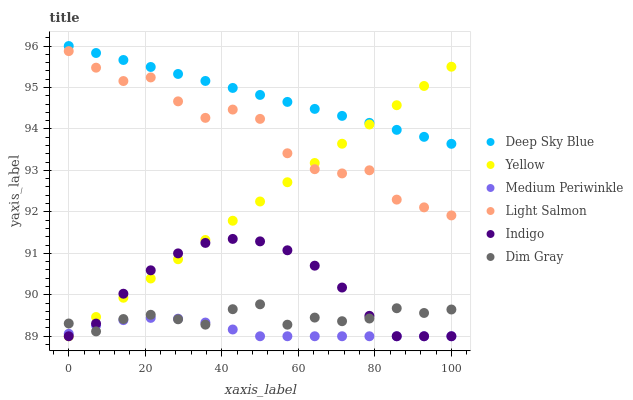Does Medium Periwinkle have the minimum area under the curve?
Answer yes or no. Yes. Does Deep Sky Blue have the maximum area under the curve?
Answer yes or no. Yes. Does Dim Gray have the minimum area under the curve?
Answer yes or no. No. Does Dim Gray have the maximum area under the curve?
Answer yes or no. No. Is Yellow the smoothest?
Answer yes or no. Yes. Is Light Salmon the roughest?
Answer yes or no. Yes. Is Dim Gray the smoothest?
Answer yes or no. No. Is Dim Gray the roughest?
Answer yes or no. No. Does Indigo have the lowest value?
Answer yes or no. Yes. Does Dim Gray have the lowest value?
Answer yes or no. No. Does Deep Sky Blue have the highest value?
Answer yes or no. Yes. Does Dim Gray have the highest value?
Answer yes or no. No. Is Dim Gray less than Deep Sky Blue?
Answer yes or no. Yes. Is Light Salmon greater than Medium Periwinkle?
Answer yes or no. Yes. Does Dim Gray intersect Medium Periwinkle?
Answer yes or no. Yes. Is Dim Gray less than Medium Periwinkle?
Answer yes or no. No. Is Dim Gray greater than Medium Periwinkle?
Answer yes or no. No. Does Dim Gray intersect Deep Sky Blue?
Answer yes or no. No. 